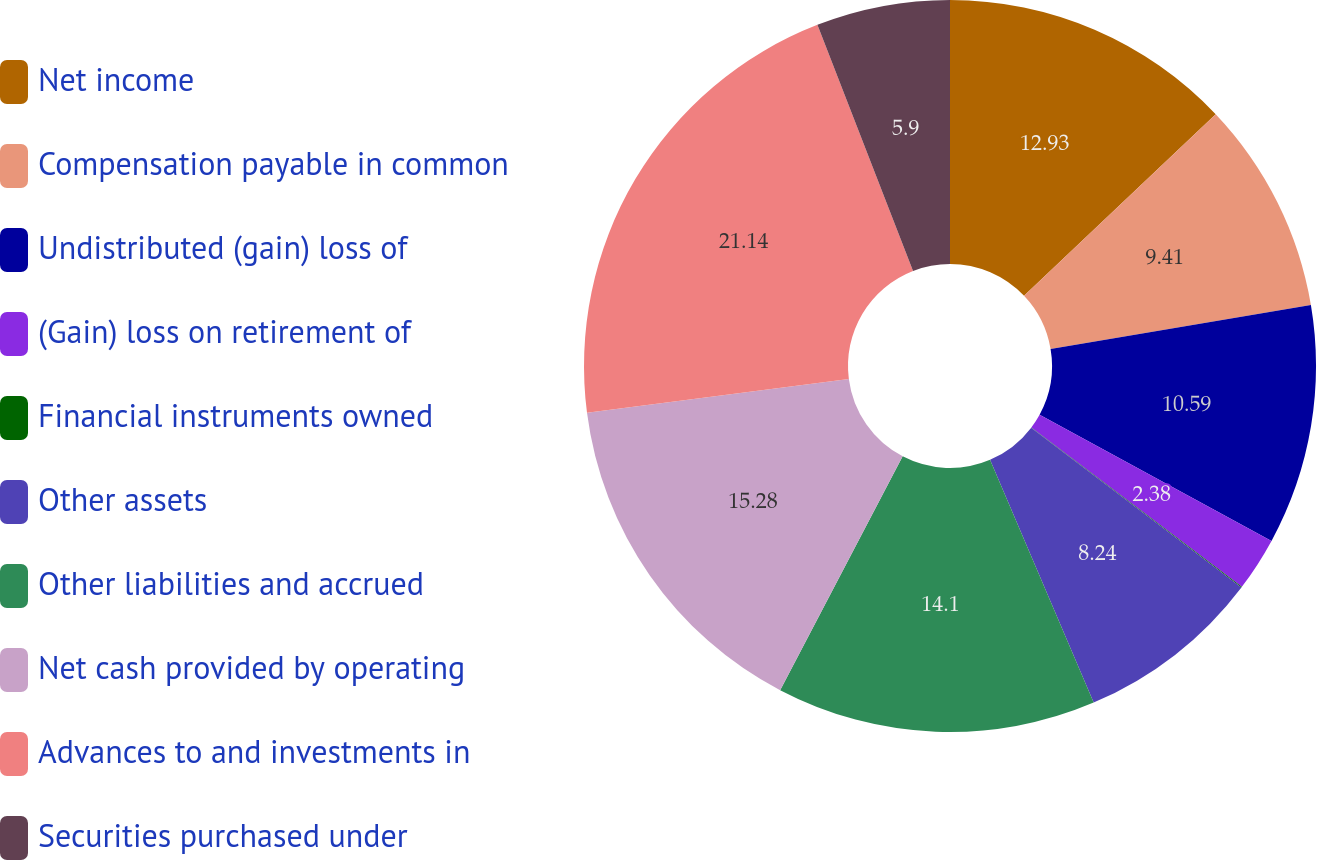Convert chart to OTSL. <chart><loc_0><loc_0><loc_500><loc_500><pie_chart><fcel>Net income<fcel>Compensation payable in common<fcel>Undistributed (gain) loss of<fcel>(Gain) loss on retirement of<fcel>Financial instruments owned<fcel>Other assets<fcel>Other liabilities and accrued<fcel>Net cash provided by operating<fcel>Advances to and investments in<fcel>Securities purchased under<nl><fcel>12.93%<fcel>9.41%<fcel>10.59%<fcel>2.38%<fcel>0.03%<fcel>8.24%<fcel>14.1%<fcel>15.28%<fcel>21.14%<fcel>5.9%<nl></chart> 